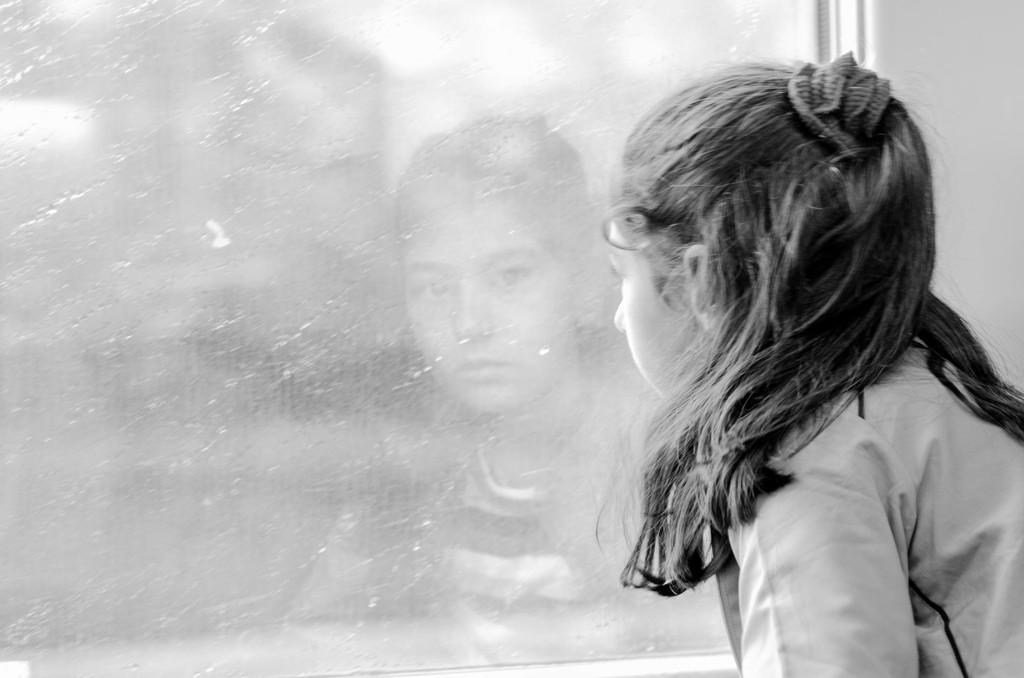Who is the main subject in the image? There is a girl in the image. What is the girl doing in the image? The girl is seated and looking into a glass window. What can be seen in the glass window? The girl's reflection is visible on the glass window. What type of bone can be seen in the girl's hand in the image? There is no bone present in the image; the girl is looking into a glass window and her reflection is visible. 